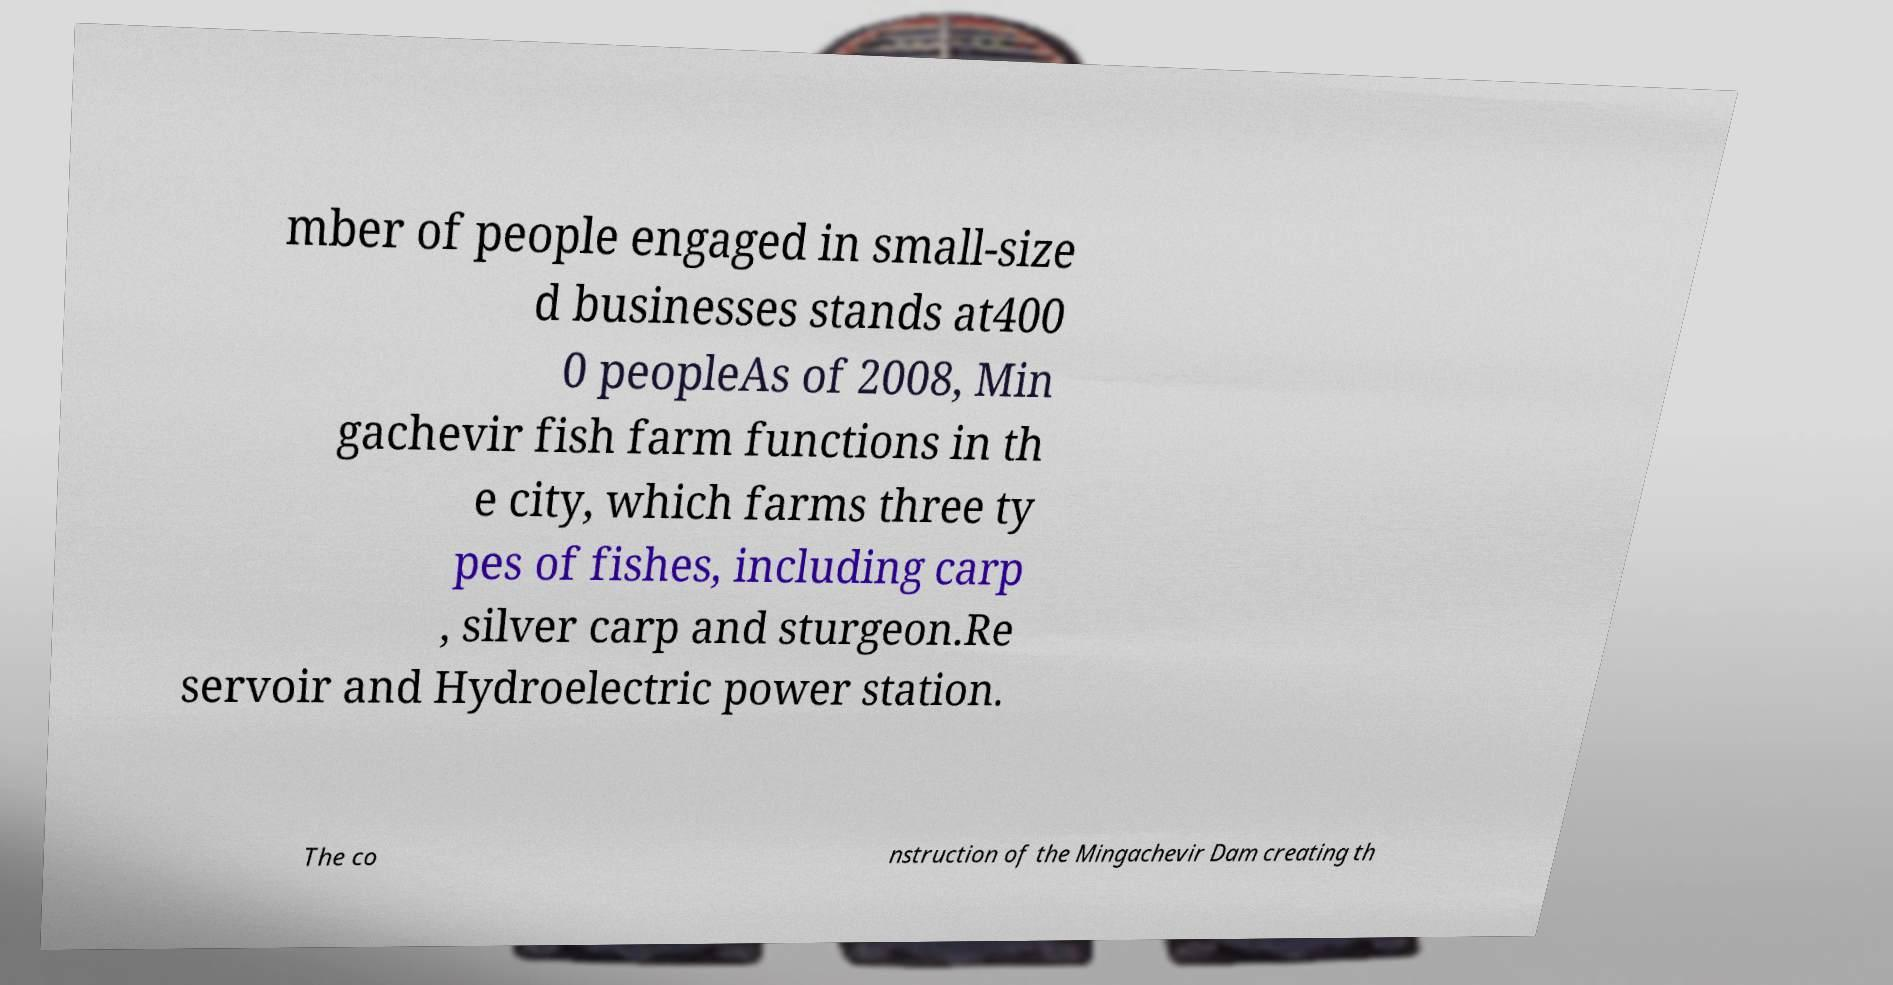Can you read and provide the text displayed in the image?This photo seems to have some interesting text. Can you extract and type it out for me? mber of people engaged in small-size d businesses stands at400 0 peopleAs of 2008, Min gachevir fish farm functions in th e city, which farms three ty pes of fishes, including carp , silver carp and sturgeon.Re servoir and Hydroelectric power station. The co nstruction of the Mingachevir Dam creating th 